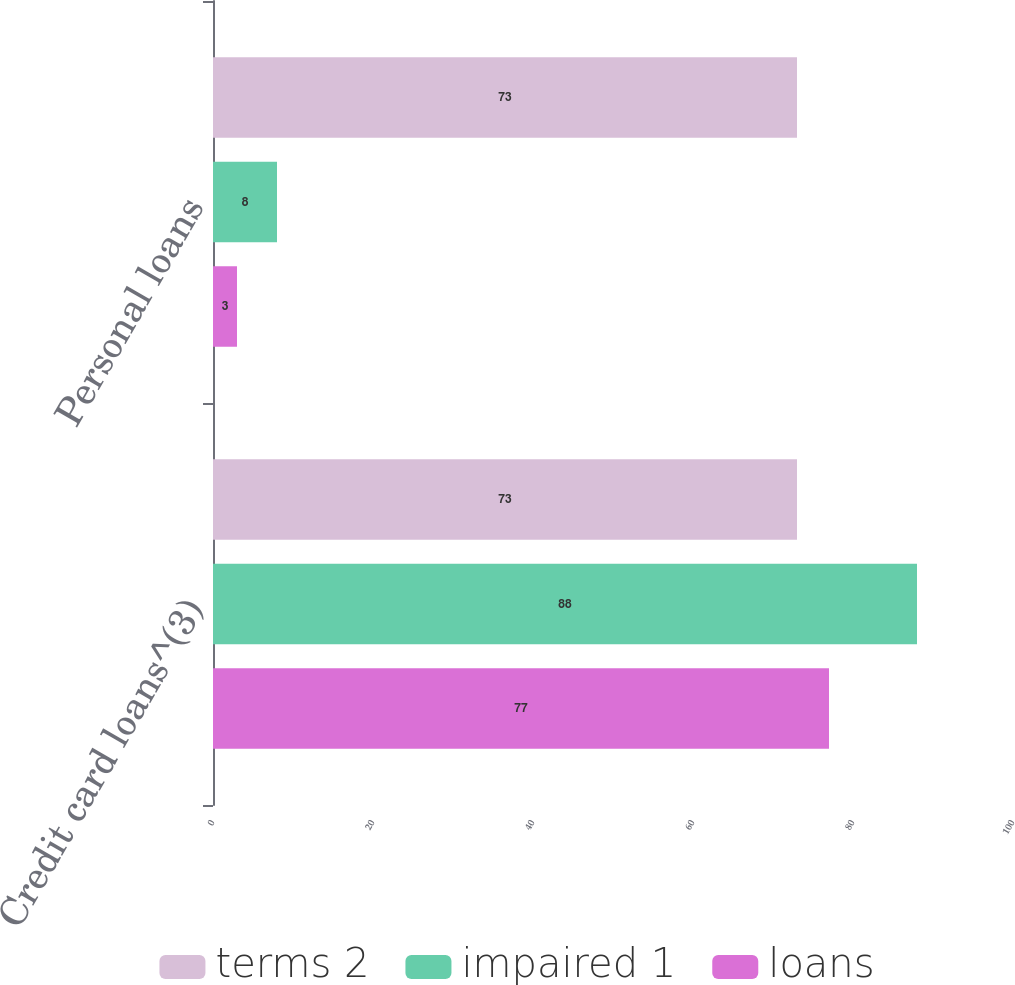Convert chart. <chart><loc_0><loc_0><loc_500><loc_500><stacked_bar_chart><ecel><fcel>Credit card loans^(3)<fcel>Personal loans<nl><fcel>terms 2<fcel>73<fcel>73<nl><fcel>impaired 1<fcel>88<fcel>8<nl><fcel>loans<fcel>77<fcel>3<nl></chart> 